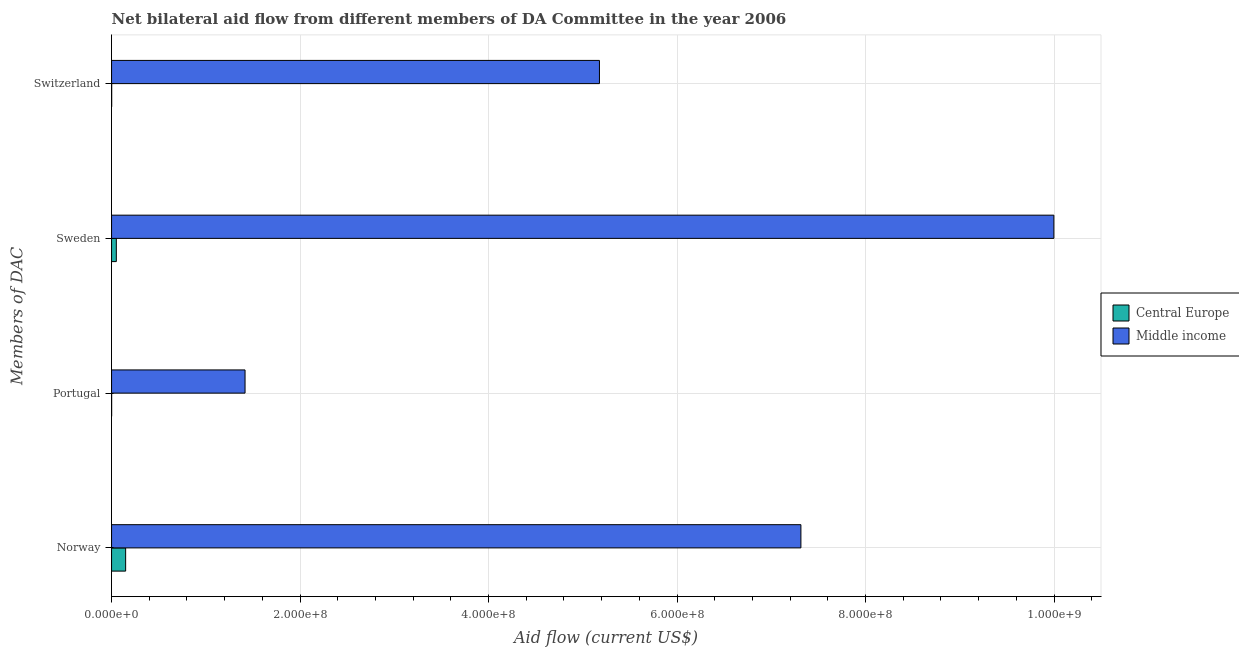How many different coloured bars are there?
Your answer should be compact. 2. How many groups of bars are there?
Ensure brevity in your answer.  4. Are the number of bars on each tick of the Y-axis equal?
Offer a terse response. Yes. How many bars are there on the 2nd tick from the top?
Your answer should be very brief. 2. How many bars are there on the 2nd tick from the bottom?
Your answer should be very brief. 2. What is the label of the 2nd group of bars from the top?
Provide a succinct answer. Sweden. What is the amount of aid given by sweden in Central Europe?
Make the answer very short. 5.06e+06. Across all countries, what is the maximum amount of aid given by switzerland?
Ensure brevity in your answer.  5.18e+08. Across all countries, what is the minimum amount of aid given by portugal?
Your answer should be compact. 8.00e+04. In which country was the amount of aid given by sweden maximum?
Ensure brevity in your answer.  Middle income. In which country was the amount of aid given by sweden minimum?
Offer a terse response. Central Europe. What is the total amount of aid given by sweden in the graph?
Give a very brief answer. 1.00e+09. What is the difference between the amount of aid given by portugal in Middle income and that in Central Europe?
Your response must be concise. 1.42e+08. What is the difference between the amount of aid given by sweden in Central Europe and the amount of aid given by portugal in Middle income?
Make the answer very short. -1.37e+08. What is the average amount of aid given by sweden per country?
Your answer should be very brief. 5.02e+08. What is the difference between the amount of aid given by sweden and amount of aid given by norway in Middle income?
Ensure brevity in your answer.  2.68e+08. What is the ratio of the amount of aid given by norway in Central Europe to that in Middle income?
Ensure brevity in your answer.  0.02. Is the amount of aid given by norway in Middle income less than that in Central Europe?
Provide a short and direct response. No. What is the difference between the highest and the second highest amount of aid given by portugal?
Provide a succinct answer. 1.42e+08. What is the difference between the highest and the lowest amount of aid given by portugal?
Provide a short and direct response. 1.42e+08. In how many countries, is the amount of aid given by norway greater than the average amount of aid given by norway taken over all countries?
Your response must be concise. 1. Is the sum of the amount of aid given by norway in Middle income and Central Europe greater than the maximum amount of aid given by sweden across all countries?
Your response must be concise. No. What does the 2nd bar from the top in Switzerland represents?
Give a very brief answer. Central Europe. How many bars are there?
Offer a terse response. 8. Are all the bars in the graph horizontal?
Make the answer very short. Yes. Are the values on the major ticks of X-axis written in scientific E-notation?
Provide a succinct answer. Yes. Does the graph contain any zero values?
Ensure brevity in your answer.  No. Does the graph contain grids?
Your answer should be compact. Yes. How are the legend labels stacked?
Provide a succinct answer. Vertical. What is the title of the graph?
Your response must be concise. Net bilateral aid flow from different members of DA Committee in the year 2006. Does "Guyana" appear as one of the legend labels in the graph?
Provide a succinct answer. No. What is the label or title of the X-axis?
Offer a very short reply. Aid flow (current US$). What is the label or title of the Y-axis?
Offer a terse response. Members of DAC. What is the Aid flow (current US$) of Central Europe in Norway?
Provide a short and direct response. 1.49e+07. What is the Aid flow (current US$) in Middle income in Norway?
Provide a succinct answer. 7.31e+08. What is the Aid flow (current US$) in Central Europe in Portugal?
Ensure brevity in your answer.  8.00e+04. What is the Aid flow (current US$) in Middle income in Portugal?
Make the answer very short. 1.42e+08. What is the Aid flow (current US$) of Central Europe in Sweden?
Your answer should be compact. 5.06e+06. What is the Aid flow (current US$) in Middle income in Sweden?
Keep it short and to the point. 1.00e+09. What is the Aid flow (current US$) of Middle income in Switzerland?
Your response must be concise. 5.18e+08. Across all Members of DAC, what is the maximum Aid flow (current US$) in Central Europe?
Your answer should be very brief. 1.49e+07. Across all Members of DAC, what is the maximum Aid flow (current US$) in Middle income?
Make the answer very short. 1.00e+09. Across all Members of DAC, what is the minimum Aid flow (current US$) of Middle income?
Offer a terse response. 1.42e+08. What is the total Aid flow (current US$) in Central Europe in the graph?
Provide a succinct answer. 2.02e+07. What is the total Aid flow (current US$) of Middle income in the graph?
Your answer should be very brief. 2.39e+09. What is the difference between the Aid flow (current US$) in Central Europe in Norway and that in Portugal?
Make the answer very short. 1.49e+07. What is the difference between the Aid flow (current US$) of Middle income in Norway and that in Portugal?
Make the answer very short. 5.90e+08. What is the difference between the Aid flow (current US$) in Central Europe in Norway and that in Sweden?
Offer a very short reply. 9.88e+06. What is the difference between the Aid flow (current US$) of Middle income in Norway and that in Sweden?
Offer a very short reply. -2.68e+08. What is the difference between the Aid flow (current US$) of Central Europe in Norway and that in Switzerland?
Give a very brief answer. 1.48e+07. What is the difference between the Aid flow (current US$) of Middle income in Norway and that in Switzerland?
Offer a very short reply. 2.14e+08. What is the difference between the Aid flow (current US$) of Central Europe in Portugal and that in Sweden?
Your answer should be compact. -4.98e+06. What is the difference between the Aid flow (current US$) in Middle income in Portugal and that in Sweden?
Your response must be concise. -8.58e+08. What is the difference between the Aid flow (current US$) of Middle income in Portugal and that in Switzerland?
Keep it short and to the point. -3.76e+08. What is the difference between the Aid flow (current US$) of Central Europe in Sweden and that in Switzerland?
Your response must be concise. 4.93e+06. What is the difference between the Aid flow (current US$) in Middle income in Sweden and that in Switzerland?
Your answer should be compact. 4.82e+08. What is the difference between the Aid flow (current US$) in Central Europe in Norway and the Aid flow (current US$) in Middle income in Portugal?
Make the answer very short. -1.27e+08. What is the difference between the Aid flow (current US$) of Central Europe in Norway and the Aid flow (current US$) of Middle income in Sweden?
Ensure brevity in your answer.  -9.85e+08. What is the difference between the Aid flow (current US$) of Central Europe in Norway and the Aid flow (current US$) of Middle income in Switzerland?
Provide a short and direct response. -5.03e+08. What is the difference between the Aid flow (current US$) in Central Europe in Portugal and the Aid flow (current US$) in Middle income in Sweden?
Provide a short and direct response. -1.00e+09. What is the difference between the Aid flow (current US$) in Central Europe in Portugal and the Aid flow (current US$) in Middle income in Switzerland?
Give a very brief answer. -5.18e+08. What is the difference between the Aid flow (current US$) in Central Europe in Sweden and the Aid flow (current US$) in Middle income in Switzerland?
Your answer should be very brief. -5.13e+08. What is the average Aid flow (current US$) of Central Europe per Members of DAC?
Give a very brief answer. 5.05e+06. What is the average Aid flow (current US$) of Middle income per Members of DAC?
Offer a terse response. 5.98e+08. What is the difference between the Aid flow (current US$) in Central Europe and Aid flow (current US$) in Middle income in Norway?
Provide a succinct answer. -7.16e+08. What is the difference between the Aid flow (current US$) in Central Europe and Aid flow (current US$) in Middle income in Portugal?
Make the answer very short. -1.42e+08. What is the difference between the Aid flow (current US$) of Central Europe and Aid flow (current US$) of Middle income in Sweden?
Give a very brief answer. -9.95e+08. What is the difference between the Aid flow (current US$) in Central Europe and Aid flow (current US$) in Middle income in Switzerland?
Provide a short and direct response. -5.18e+08. What is the ratio of the Aid flow (current US$) of Central Europe in Norway to that in Portugal?
Offer a terse response. 186.75. What is the ratio of the Aid flow (current US$) of Middle income in Norway to that in Portugal?
Give a very brief answer. 5.16. What is the ratio of the Aid flow (current US$) in Central Europe in Norway to that in Sweden?
Your answer should be compact. 2.95. What is the ratio of the Aid flow (current US$) in Middle income in Norway to that in Sweden?
Ensure brevity in your answer.  0.73. What is the ratio of the Aid flow (current US$) in Central Europe in Norway to that in Switzerland?
Offer a very short reply. 114.92. What is the ratio of the Aid flow (current US$) in Middle income in Norway to that in Switzerland?
Offer a very short reply. 1.41. What is the ratio of the Aid flow (current US$) in Central Europe in Portugal to that in Sweden?
Offer a terse response. 0.02. What is the ratio of the Aid flow (current US$) in Middle income in Portugal to that in Sweden?
Offer a very short reply. 0.14. What is the ratio of the Aid flow (current US$) in Central Europe in Portugal to that in Switzerland?
Keep it short and to the point. 0.62. What is the ratio of the Aid flow (current US$) in Middle income in Portugal to that in Switzerland?
Your response must be concise. 0.27. What is the ratio of the Aid flow (current US$) of Central Europe in Sweden to that in Switzerland?
Provide a succinct answer. 38.92. What is the ratio of the Aid flow (current US$) of Middle income in Sweden to that in Switzerland?
Offer a terse response. 1.93. What is the difference between the highest and the second highest Aid flow (current US$) of Central Europe?
Provide a succinct answer. 9.88e+06. What is the difference between the highest and the second highest Aid flow (current US$) in Middle income?
Offer a very short reply. 2.68e+08. What is the difference between the highest and the lowest Aid flow (current US$) in Central Europe?
Your answer should be very brief. 1.49e+07. What is the difference between the highest and the lowest Aid flow (current US$) in Middle income?
Give a very brief answer. 8.58e+08. 